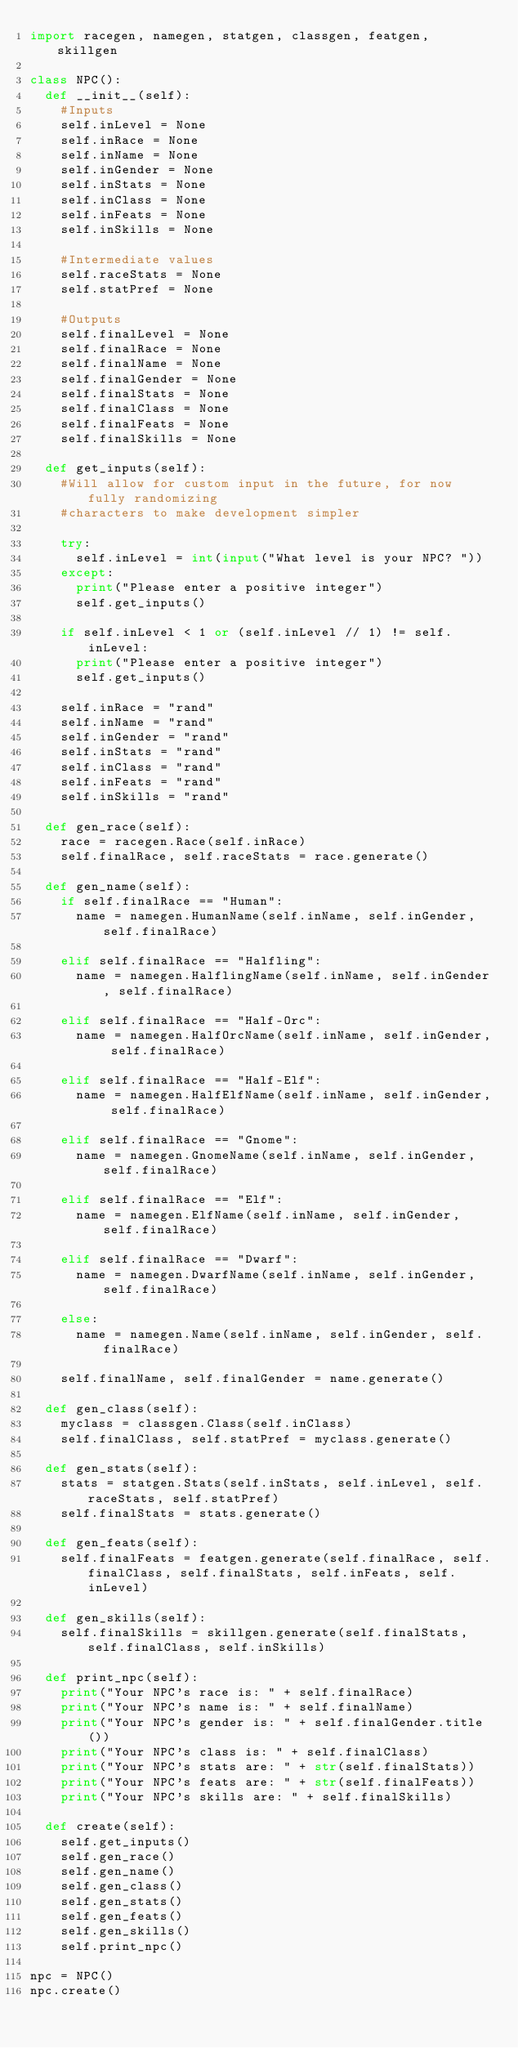<code> <loc_0><loc_0><loc_500><loc_500><_Python_>import racegen, namegen, statgen, classgen, featgen, skillgen

class NPC():
	def __init__(self):
		#Inputs
		self.inLevel = None
		self.inRace = None
		self.inName = None
		self.inGender = None
		self.inStats = None
		self.inClass = None
		self.inFeats = None
		self.inSkills = None

		#Intermediate values
		self.raceStats = None
		self.statPref = None

		#Outputs
		self.finalLevel = None
		self.finalRace = None
		self.finalName = None
		self.finalGender = None
		self.finalStats = None
		self.finalClass = None
		self.finalFeats = None
		self.finalSkills = None

	def get_inputs(self):
		#Will allow for custom input in the future, for now fully randomizing
		#characters to make development simpler

		try:
			self.inLevel = int(input("What level is your NPC? "))
		except:
			print("Please enter a positive integer")
			self.get_inputs()

		if self.inLevel < 1 or (self.inLevel // 1) != self.inLevel:
			print("Please enter a positive integer")
			self.get_inputs()

		self.inRace = "rand"
		self.inName = "rand"
		self.inGender = "rand"
		self.inStats = "rand"
		self.inClass = "rand"
		self.inFeats = "rand"
		self.inSkills = "rand"

	def gen_race(self):
		race = racegen.Race(self.inRace)
		self.finalRace, self.raceStats = race.generate()

	def gen_name(self):
		if self.finalRace == "Human":
			name = namegen.HumanName(self.inName, self.inGender, self.finalRace)

		elif self.finalRace == "Halfling":
			name = namegen.HalflingName(self.inName, self.inGender, self.finalRace)

		elif self.finalRace == "Half-Orc":
			name = namegen.HalfOrcName(self.inName, self.inGender, self.finalRace)

		elif self.finalRace == "Half-Elf":
			name = namegen.HalfElfName(self.inName, self.inGender, self.finalRace)

		elif self.finalRace == "Gnome":
			name = namegen.GnomeName(self.inName, self.inGender, self.finalRace)

		elif self.finalRace == "Elf":
			name = namegen.ElfName(self.inName, self.inGender, self.finalRace)

		elif self.finalRace == "Dwarf":
			name = namegen.DwarfName(self.inName, self.inGender, self.finalRace)

		else:
			name = namegen.Name(self.inName, self.inGender, self.finalRace)

		self.finalName, self.finalGender = name.generate()

	def gen_class(self):
		myclass = classgen.Class(self.inClass)
		self.finalClass, self.statPref = myclass.generate()

	def gen_stats(self):
		stats = statgen.Stats(self.inStats, self.inLevel, self.raceStats, self.statPref)
		self.finalStats = stats.generate()

	def gen_feats(self):
		self.finalFeats = featgen.generate(self.finalRace, self.finalClass, self.finalStats, self.inFeats, self.inLevel)

	def gen_skills(self):
		self.finalSkills = skillgen.generate(self.finalStats, self.finalClass, self.inSkills)

	def print_npc(self):
		print("Your NPC's race is: " + self.finalRace)
		print("Your NPC's name is: " + self.finalName)
		print("Your NPC's gender is: " + self.finalGender.title())
		print("Your NPC's class is: " + self.finalClass)
		print("Your NPC's stats are: " + str(self.finalStats))
		print("Your NPC's feats are: " + str(self.finalFeats))
		print("Your NPC's skills are: " + self.finalSkills)

	def create(self):
		self.get_inputs()
		self.gen_race()
		self.gen_name()
		self.gen_class()
		self.gen_stats()
		self.gen_feats()
		self.gen_skills()
		self.print_npc()

npc = NPC()
npc.create()
</code> 